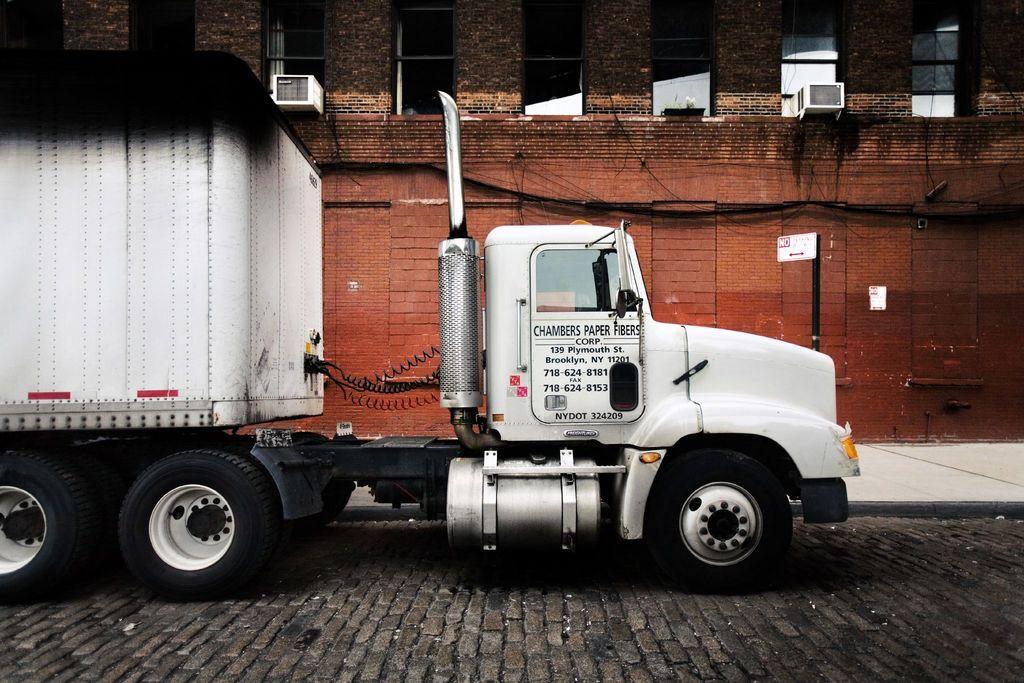Describe this image in one or two sentences. In this picture I can see the path in front, on which there is a truck and I see something is written on it. In the background I can see a building and I see number of windows. 